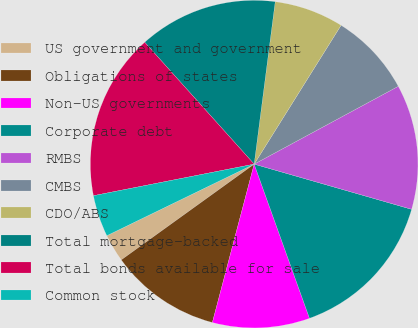Convert chart to OTSL. <chart><loc_0><loc_0><loc_500><loc_500><pie_chart><fcel>US government and government<fcel>Obligations of states<fcel>Non-US governments<fcel>Corporate debt<fcel>RMBS<fcel>CMBS<fcel>CDO/ABS<fcel>Total mortgage-backed<fcel>Total bonds available for sale<fcel>Common stock<nl><fcel>2.74%<fcel>10.96%<fcel>9.59%<fcel>15.07%<fcel>12.33%<fcel>8.22%<fcel>6.85%<fcel>13.7%<fcel>16.44%<fcel>4.11%<nl></chart> 